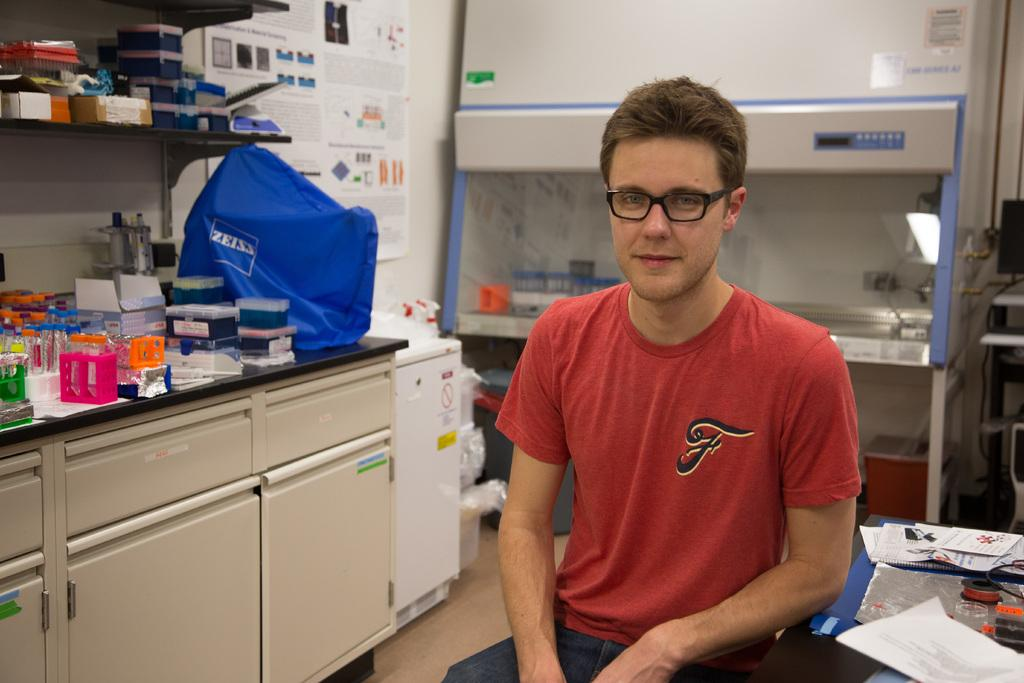Provide a one-sentence caption for the provided image. A man sitting in a lab with a red shirt and a "F" on the shirt. 